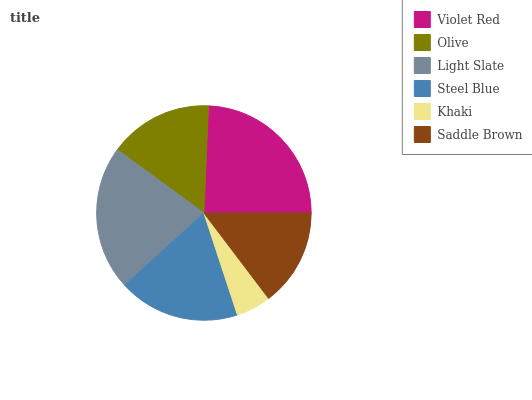Is Khaki the minimum?
Answer yes or no. Yes. Is Violet Red the maximum?
Answer yes or no. Yes. Is Olive the minimum?
Answer yes or no. No. Is Olive the maximum?
Answer yes or no. No. Is Violet Red greater than Olive?
Answer yes or no. Yes. Is Olive less than Violet Red?
Answer yes or no. Yes. Is Olive greater than Violet Red?
Answer yes or no. No. Is Violet Red less than Olive?
Answer yes or no. No. Is Steel Blue the high median?
Answer yes or no. Yes. Is Olive the low median?
Answer yes or no. Yes. Is Olive the high median?
Answer yes or no. No. Is Saddle Brown the low median?
Answer yes or no. No. 